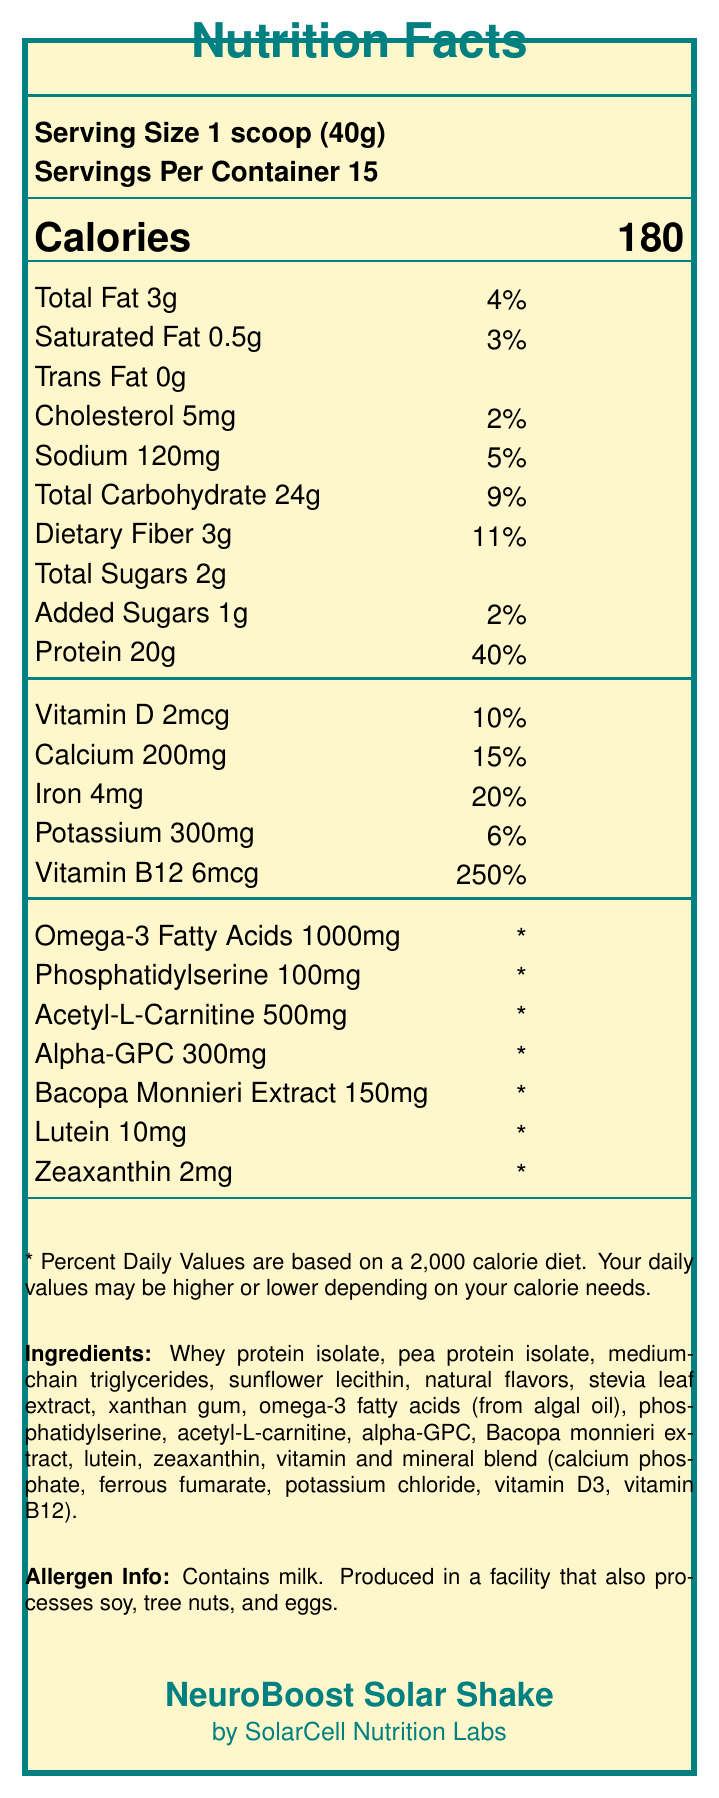what is the serving size of NeuroBoost Solar Shake? The serving size is listed at the beginning of the document as "Serving Size 1 scoop (40g)".
Answer: 1 scoop (40g) how many servings are in each container of NeuroBoost Solar Shake? The document states "Servings Per Container 15".
Answer: 15 what is the percentage of daily value for protein in NeuroBoost Solar Shake? The daily value percentage for protein is listed as "Protein 20g 40%".
Answer: 40% what is the amount of vitamin B12 in NeuroBoost Solar Shake? Vitamin B12 amount is listed as "Vitamin B12 6mcg".
Answer: 6mcg what are some main ingredients in NeuroBoost Solar Shake? The ingredients are listed under the text "Ingredients:" in the document.
Answer: Whey protein isolate, pea protein isolate, medium-chain triglycerides, sunflower lecithin, natural flavors, stevia leaf extract, xanthan gum, omega-3 fatty acids (from algal oil), phosphatidylserine, acetyl-L-carnitine, alpha-GPC, Bacopa monnieri extract, lutein, zeaxanthin, vitamin and mineral blend (calcium phosphate, ferrous fumarate, potassium chloride, vitamin D3, vitamin B12). which nutrient has the highest daily value percentage? 
A. Vitamin D 
B. Iron 
C. Calcium 
D. Vitamin B12 Vitamin B12 has a daily value percentage of 250%, which is higher than the others listed.
Answer: D how many milligrams of sodium does each serving of NeuroBoost Solar Shake contain? 
1. 100mg 
2. 120mg 
3. 150mg 
4. 200mg The amount of sodium is listed as "Sodium 120mg".
Answer: 2 does NeuroBoost Solar Shake contain any cholesterol? The document lists "Cholesterol 5mg", confirming the presence of cholesterol.
Answer: Yes does NeuroBoost Solar Shake contain any trans fat? The document lists "Trans Fat 0g", indicating there is no trans fat.
Answer: No provide a summary of the Nutrition Facts Label for NeuroBoost Solar Shake. The summary encapsulates the main nutritional elements, ingredients, and specific health-related information, including allergen warnings and manufacturing details.
Answer: NeuroBoost Solar Shake is a fortified meal replacement shake designed to support cognitive function and memory. Each 40g scoop serving delivers 180 calories, 3g of total fat, 24g of carbohydrates, and 20g of protein. It provides various vitamins and minerals including 250% daily value of Vitamin B12. It includes ingredients like whey protein isolate, pea protein isolate, and numerous cognitive enhancers like phosphatidylserine and Bacopa monnieri extract. It contains milk and is made in a facility that processes soy, tree nuts, and eggs. what is the source of the omega-3 fatty acids in NeuroBoost Solar Shake? The document lists omega-3 fatty acids as one of the ingredients but does not provide the specific source within the visual information.
Answer: Cannot be determined 